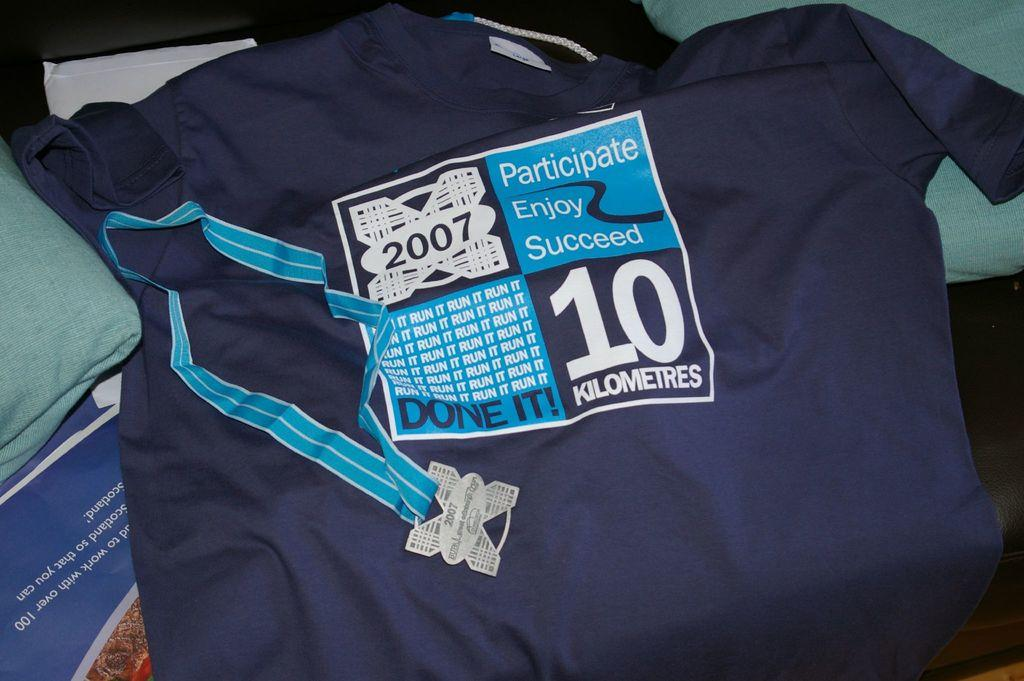<image>
Create a compact narrative representing the image presented. A blue outfit displays an image from a 10k race which says Participate Enjoy Succeed. 